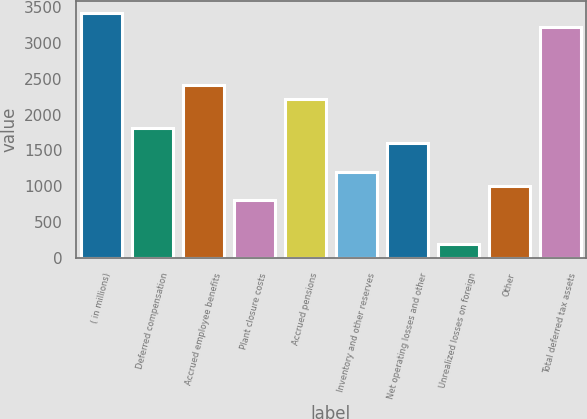Convert chart to OTSL. <chart><loc_0><loc_0><loc_500><loc_500><bar_chart><fcel>( in millions)<fcel>Deferred compensation<fcel>Accrued employee benefits<fcel>Plant closure costs<fcel>Accrued pensions<fcel>Inventory and other reserves<fcel>Net operating losses and other<fcel>Unrealized losses on foreign<fcel>Other<fcel>Total deferred tax assets<nl><fcel>3412.15<fcel>1808.55<fcel>2409.9<fcel>806.3<fcel>2209.45<fcel>1207.2<fcel>1608.1<fcel>204.95<fcel>1006.75<fcel>3211.7<nl></chart> 